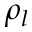Convert formula to latex. <formula><loc_0><loc_0><loc_500><loc_500>\rho _ { l }</formula> 